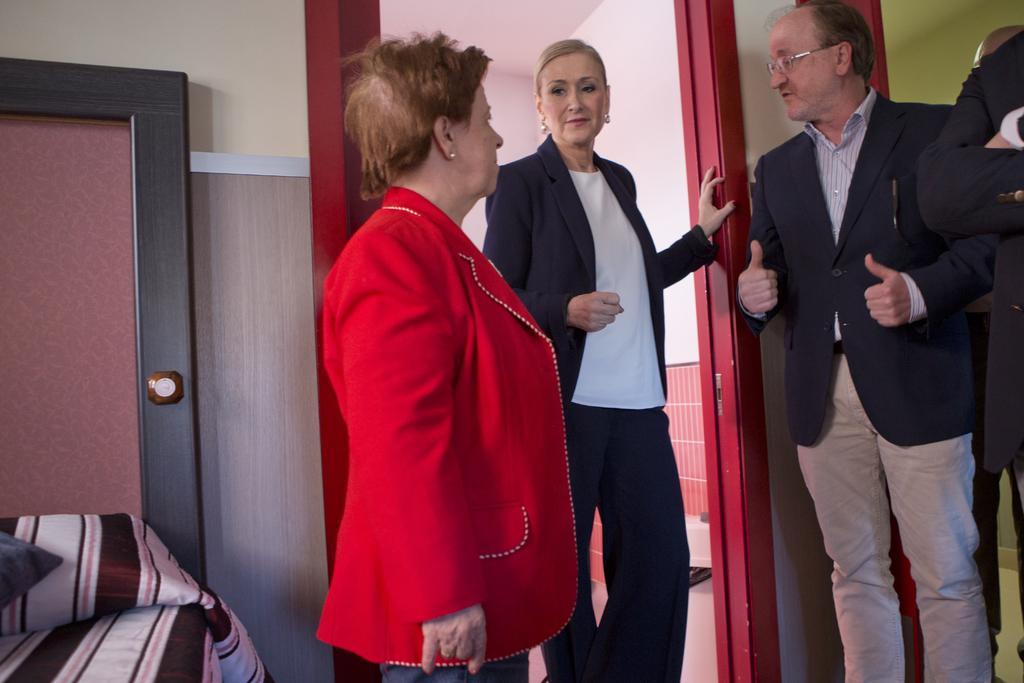In one or two sentences, can you explain what this image depicts? In this picture there are people standing and we can see cloth and door. In the background of the image we can see wall. 